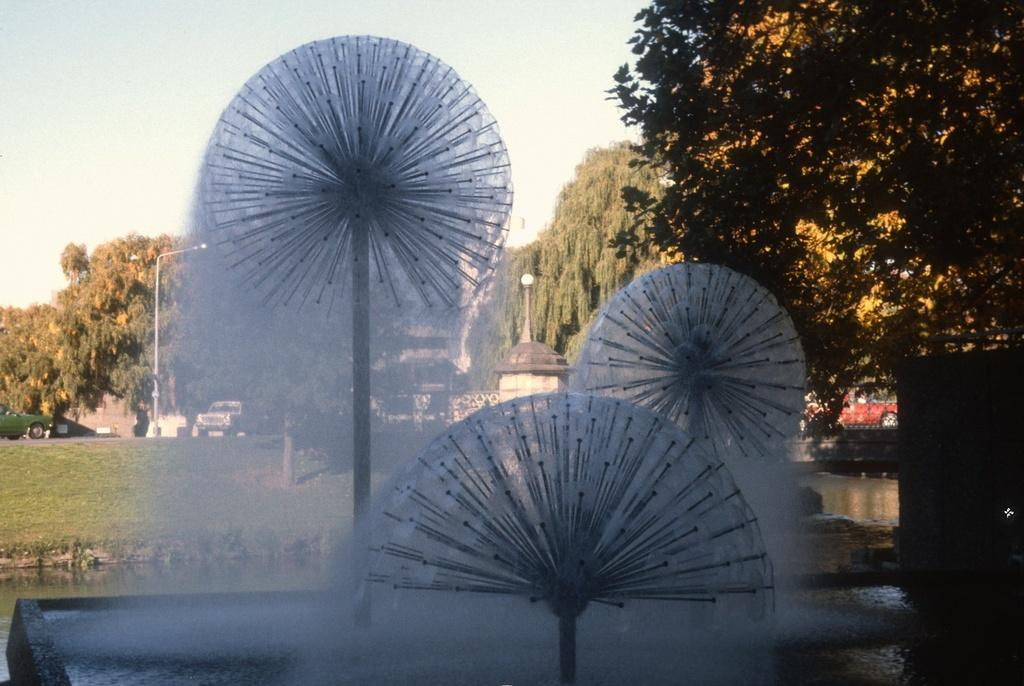What is the main feature in the image? There is a fountain in the image. What else can be seen in the image besides the fountain? There are poles, a building, trees, plants, grass, a car, street lights, and a shed visible in the image. What is the background of the image like? The background of the image includes a building, trees, plants, grass, a car, street lights, and a shed. What is visible at the top of the image? The sky is visible at the top of the image. What type of sand can be seen on the knee of the person in the image? There is no person present in the image, and therefore no knee or sand can be observed. What kind of apparatus is being used by the person in the image? There is no person present in the image, and therefore no apparatus can be observed. 